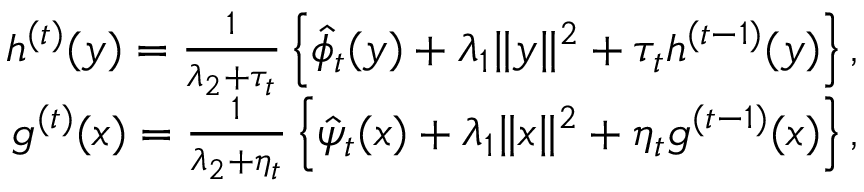Convert formula to latex. <formula><loc_0><loc_0><loc_500><loc_500>\begin{array} { r } { h ^ { ( t ) } ( y ) = \frac { 1 } { \lambda _ { 2 } + \tau _ { t } } \left \{ \hat { \phi } _ { t } ( y ) + \lambda _ { 1 } \| y \| ^ { 2 } + \tau _ { t } h ^ { ( t - 1 ) } ( y ) \right \} , } \\ { g ^ { ( t ) } ( x ) = \frac { 1 } { \lambda _ { 2 } + \eta _ { t } } \left \{ \hat { \psi } _ { t } ( x ) + \lambda _ { 1 } \| x \| ^ { 2 } + \eta _ { t } g ^ { ( t - 1 ) } ( x ) \right \} , } \end{array}</formula> 